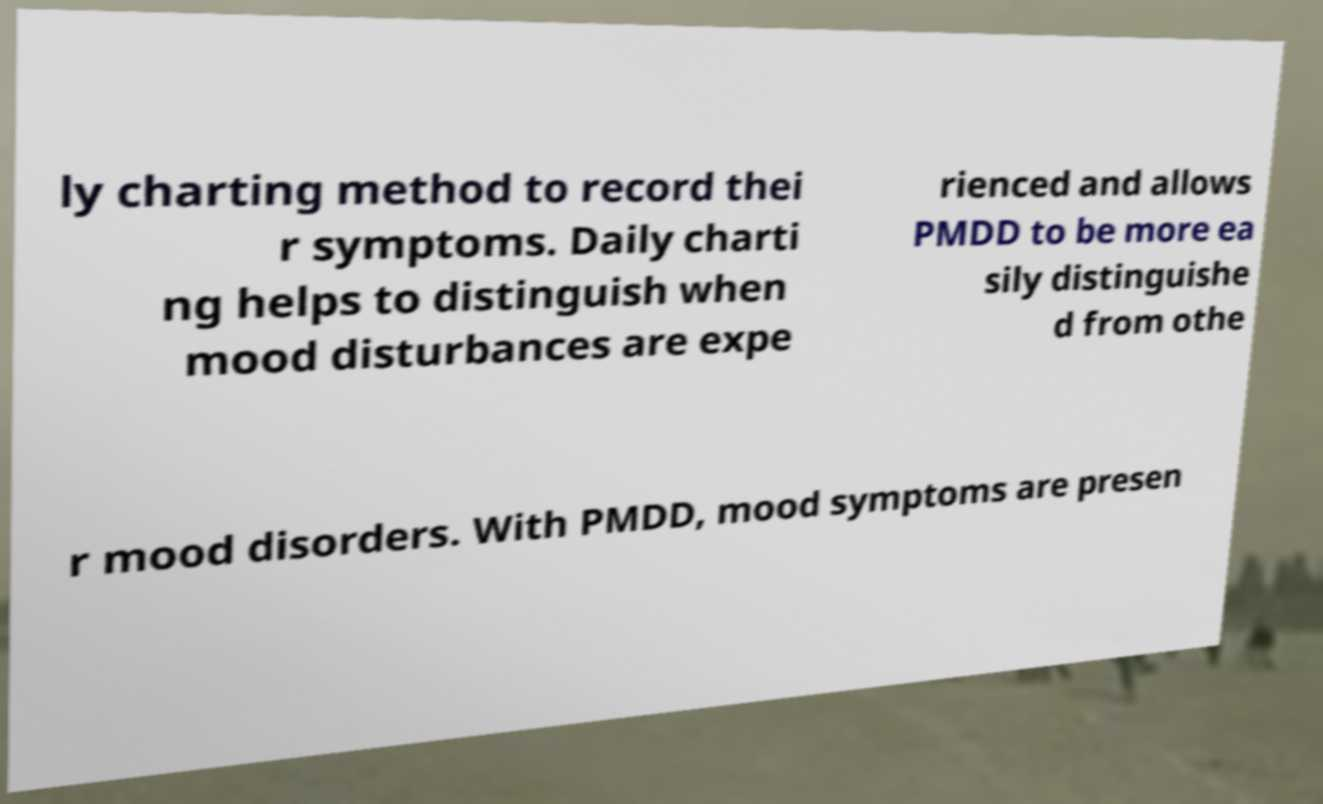There's text embedded in this image that I need extracted. Can you transcribe it verbatim? ly charting method to record thei r symptoms. Daily charti ng helps to distinguish when mood disturbances are expe rienced and allows PMDD to be more ea sily distinguishe d from othe r mood disorders. With PMDD, mood symptoms are presen 